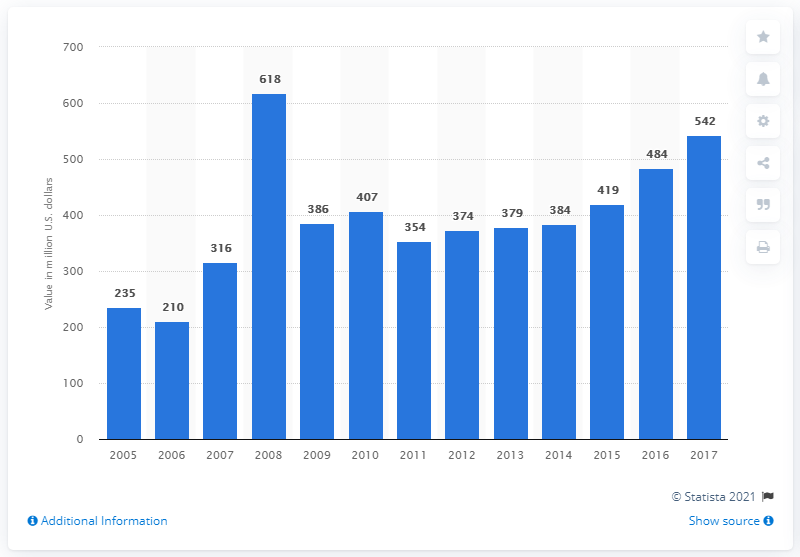List a handful of essential elements in this visual. During the period between 2005 and 2017, a total of 542 million pounds of magnesium was recycled from scrap in the United States. 